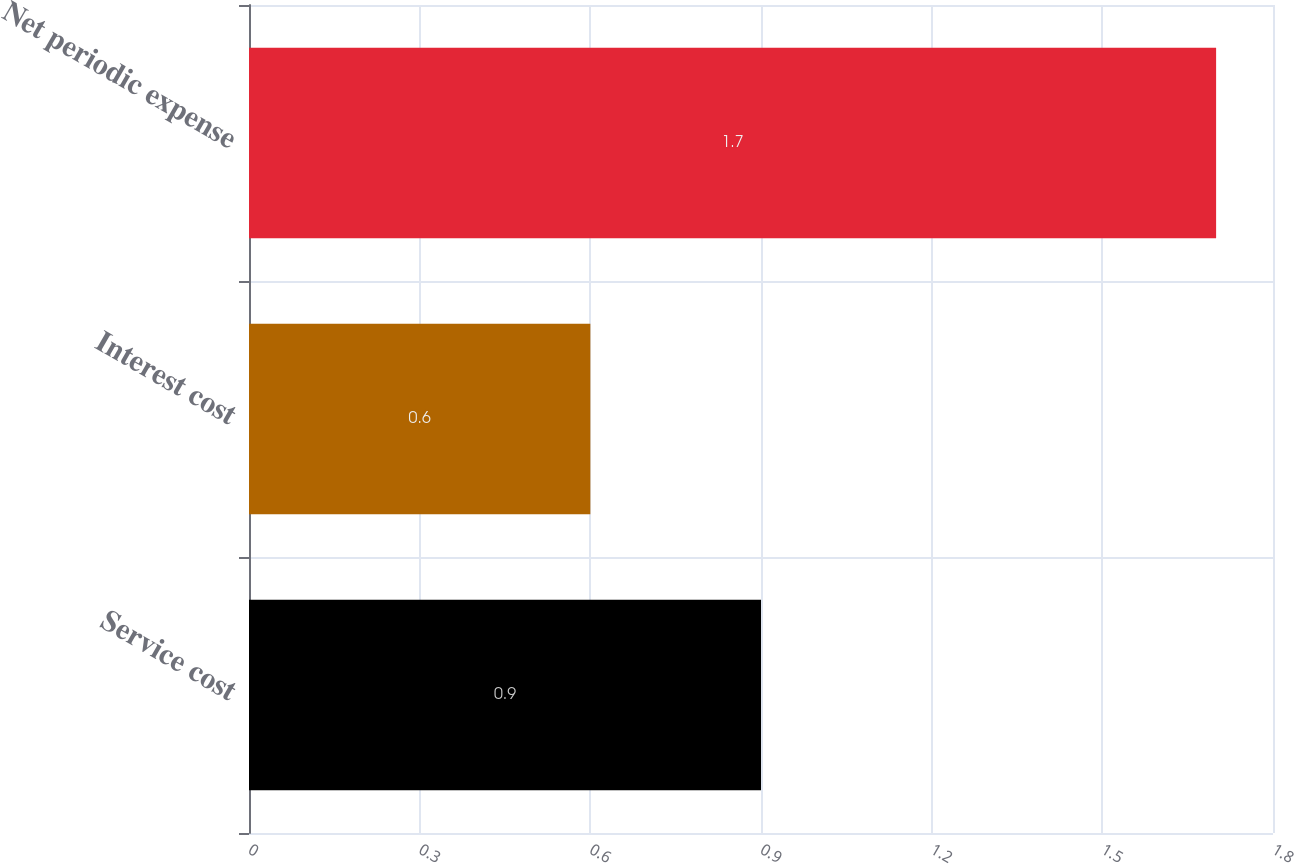<chart> <loc_0><loc_0><loc_500><loc_500><bar_chart><fcel>Service cost<fcel>Interest cost<fcel>Net periodic expense<nl><fcel>0.9<fcel>0.6<fcel>1.7<nl></chart> 